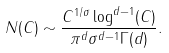Convert formula to latex. <formula><loc_0><loc_0><loc_500><loc_500>N ( C ) \sim \frac { C ^ { 1 / \sigma } \log ^ { d - 1 } ( C ) } { \pi ^ { d } \sigma ^ { d - 1 } \Gamma ( d ) } .</formula> 